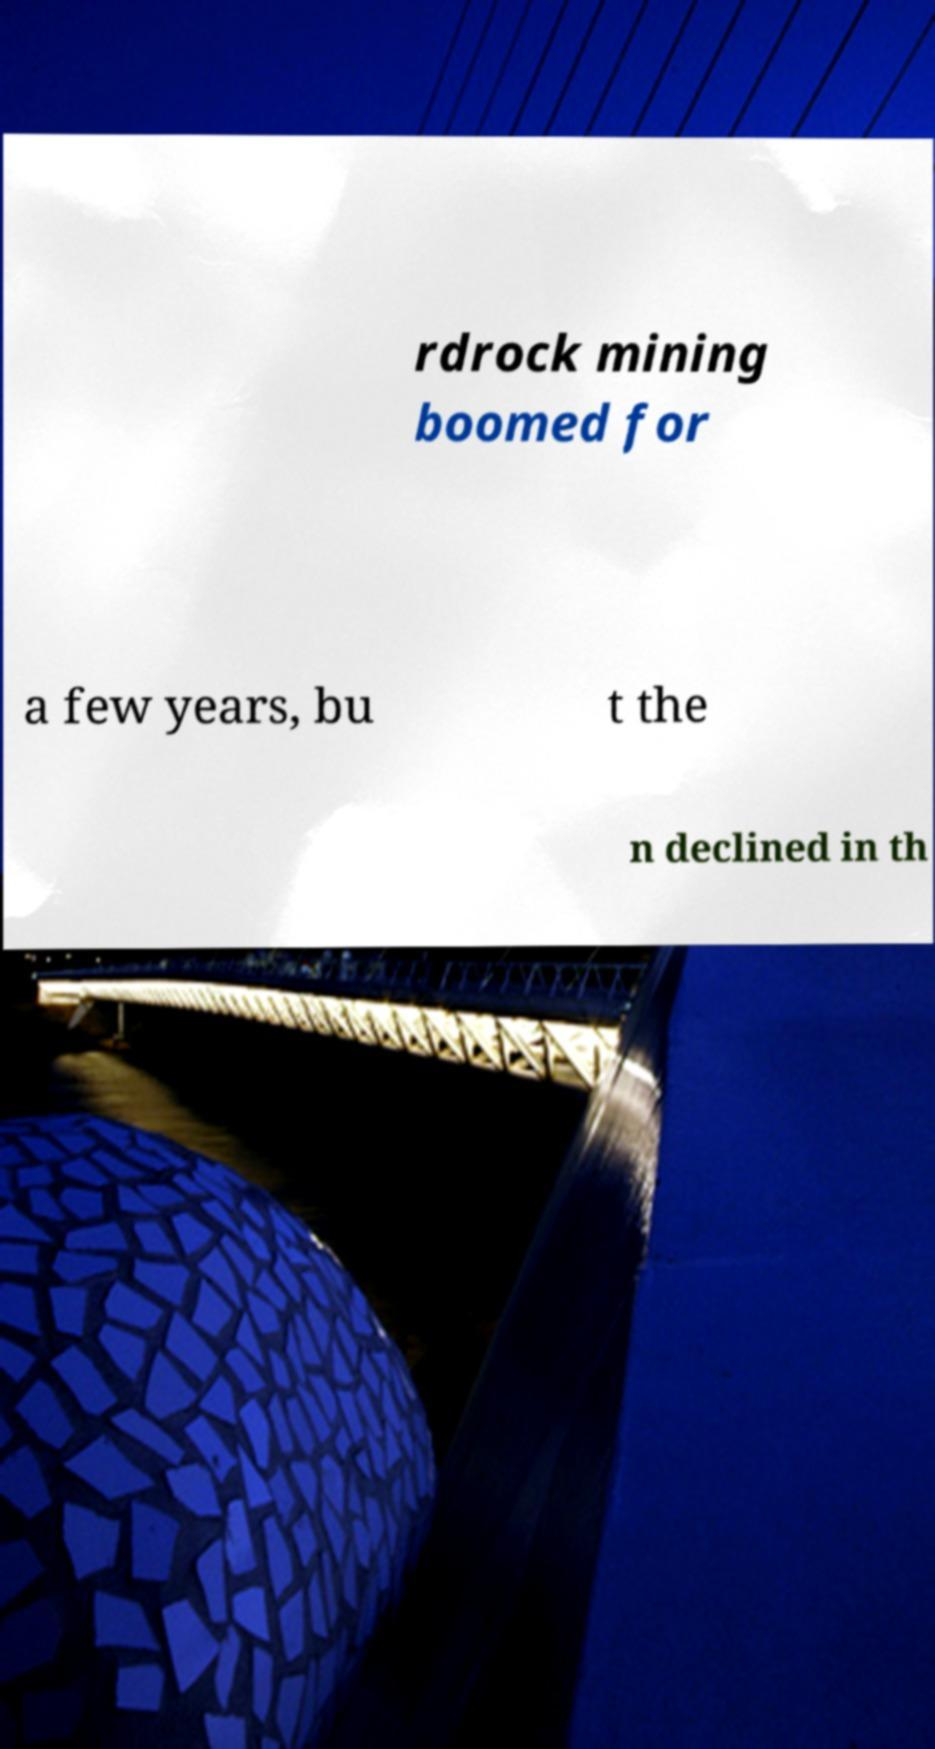For documentation purposes, I need the text within this image transcribed. Could you provide that? rdrock mining boomed for a few years, bu t the n declined in th 